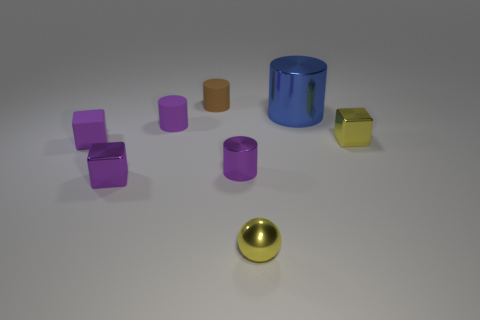Subtract all small purple rubber cylinders. How many cylinders are left? 3 Subtract all cyan cubes. How many purple cylinders are left? 2 Add 1 brown cylinders. How many objects exist? 9 Subtract all brown cylinders. How many cylinders are left? 3 Subtract all spheres. How many objects are left? 7 Subtract all purple matte cubes. Subtract all large shiny cylinders. How many objects are left? 6 Add 3 tiny matte cubes. How many tiny matte cubes are left? 4 Add 6 small purple metal cylinders. How many small purple metal cylinders exist? 7 Subtract 0 brown spheres. How many objects are left? 8 Subtract all green blocks. Subtract all purple cylinders. How many blocks are left? 3 